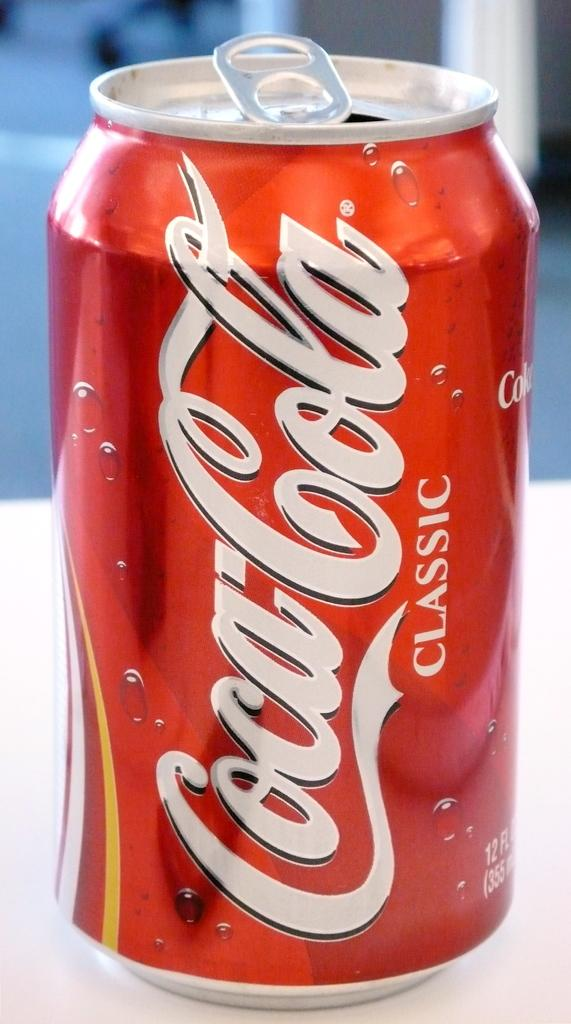<image>
Describe the image concisely. A red cola can that says Coca Cola Classic 